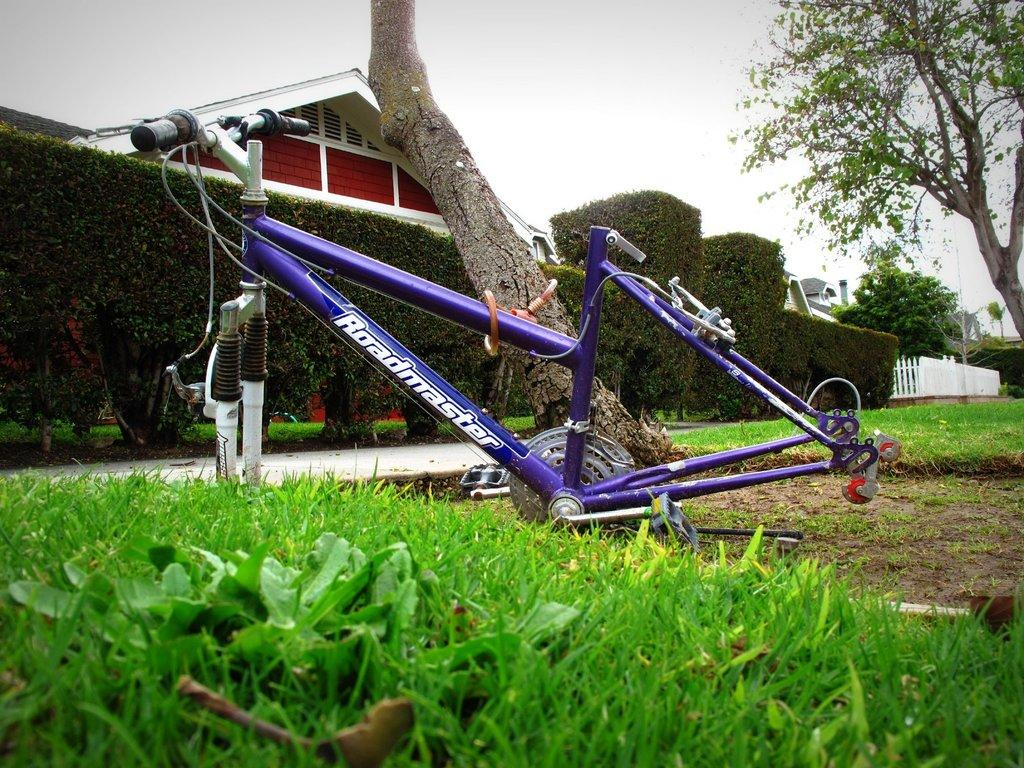What type of vegetation is visible in the image? There is grass in the image. What type of object can be seen in the image that is typically used for transportation? There is a bicycle frame in the image. What type of natural scenery is visible in the image? There are trees in the image. What type of structures can be seen in the background of the image? There are houses in the background of the image. Where is the lunchroom located in the image? There is no lunchroom present in the image. What type of furniture is visible in the image? There is no furniture visible in the image. Is there a bed present in the image? There is no bed present in the image. 